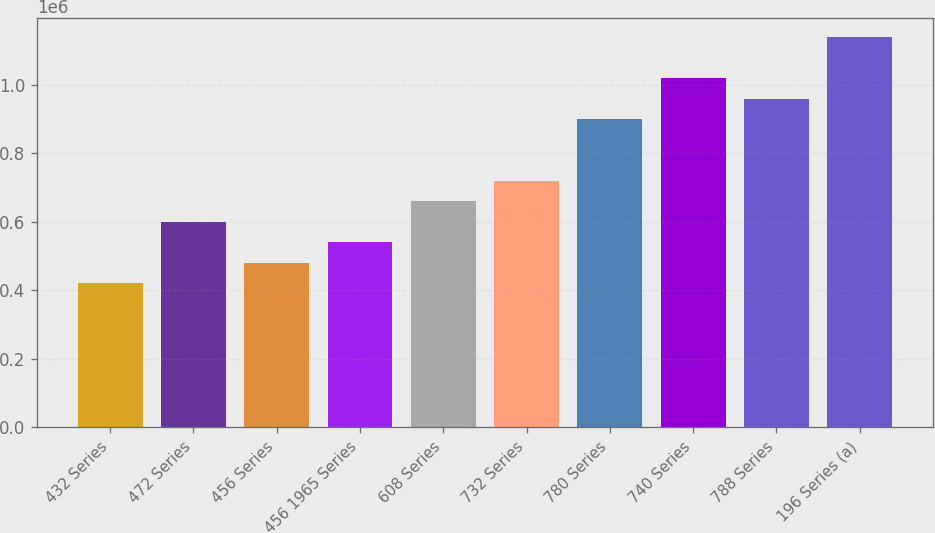Convert chart. <chart><loc_0><loc_0><loc_500><loc_500><bar_chart><fcel>432 Series<fcel>472 Series<fcel>456 Series<fcel>456 1965 Series<fcel>608 Series<fcel>732 Series<fcel>780 Series<fcel>740 Series<fcel>788 Series<fcel>196 Series (a)<nl><fcel>420496<fcel>600000<fcel>480331<fcel>540166<fcel>659834<fcel>719669<fcel>899172<fcel>1.01884e+06<fcel>959007<fcel>1.13851e+06<nl></chart> 